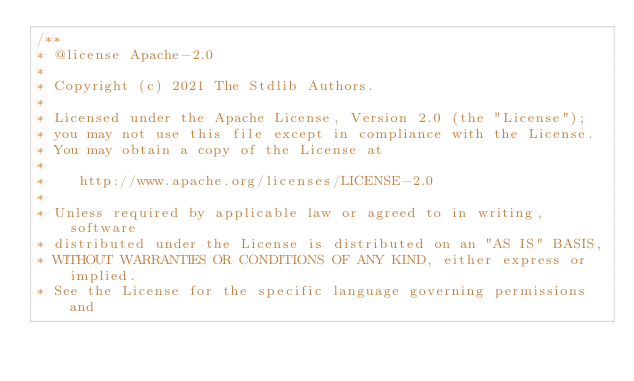Convert code to text. <code><loc_0><loc_0><loc_500><loc_500><_JavaScript_>/**
* @license Apache-2.0
*
* Copyright (c) 2021 The Stdlib Authors.
*
* Licensed under the Apache License, Version 2.0 (the "License");
* you may not use this file except in compliance with the License.
* You may obtain a copy of the License at
*
*    http://www.apache.org/licenses/LICENSE-2.0
*
* Unless required by applicable law or agreed to in writing, software
* distributed under the License is distributed on an "AS IS" BASIS,
* WITHOUT WARRANTIES OR CONDITIONS OF ANY KIND, either express or implied.
* See the License for the specific language governing permissions and</code> 